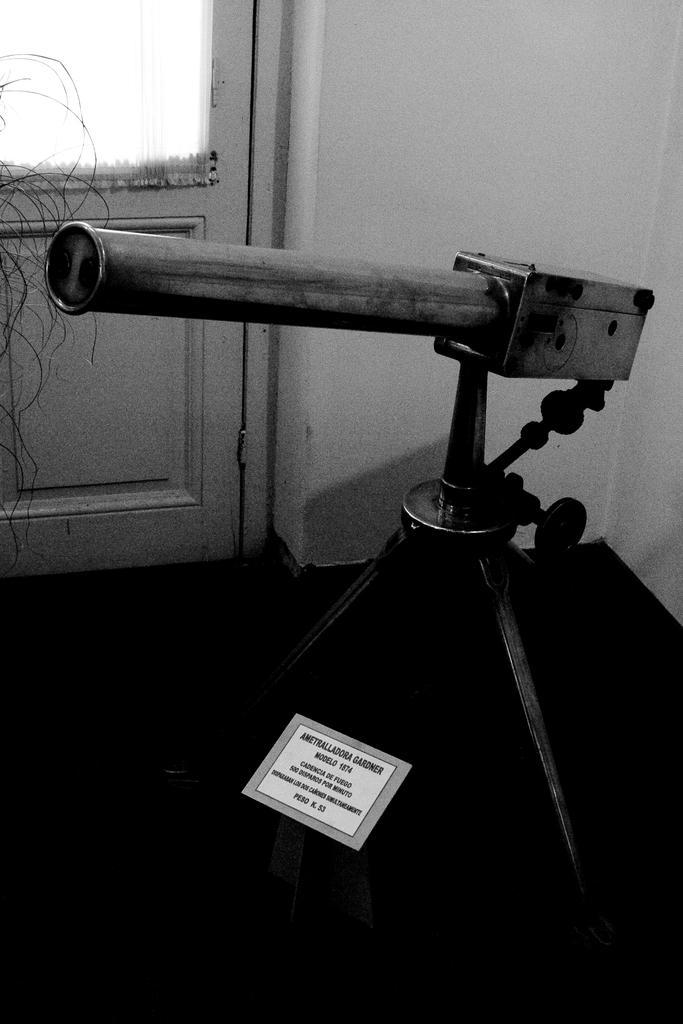In one or two sentences, can you explain what this image depicts? This is a black and white pic. There is an object on a stand and a tag on the floor. In the background we can see a door and wall. 